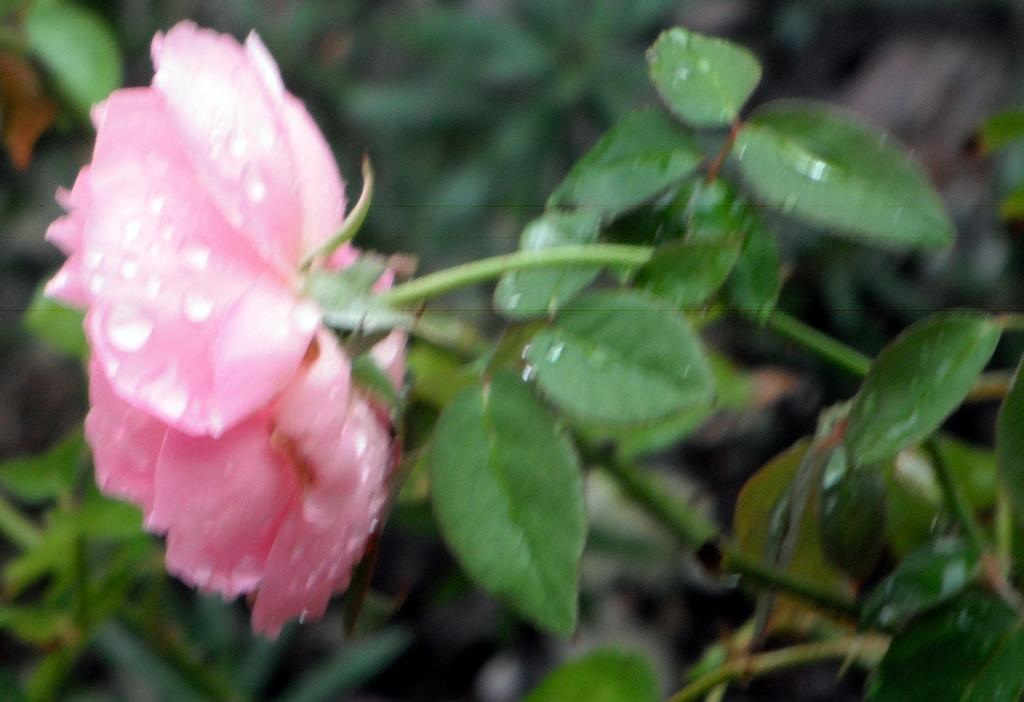What type of plant can be seen in the picture? There is a flowering plant in the picture. What color are the leaves of the plant? The plant has green leaves. Where is the girl sitting on the roof in the image? There is no girl or roof present in the image; it only features a flowering plant with green leaves. 